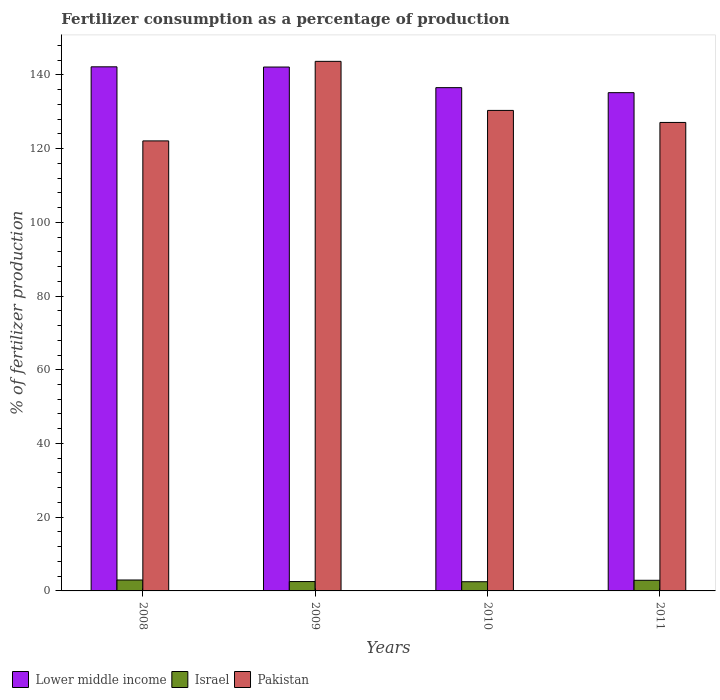How many groups of bars are there?
Keep it short and to the point. 4. What is the percentage of fertilizers consumed in Pakistan in 2010?
Provide a short and direct response. 130.35. Across all years, what is the maximum percentage of fertilizers consumed in Lower middle income?
Your answer should be compact. 142.18. Across all years, what is the minimum percentage of fertilizers consumed in Pakistan?
Keep it short and to the point. 122.08. In which year was the percentage of fertilizers consumed in Pakistan maximum?
Offer a very short reply. 2009. What is the total percentage of fertilizers consumed in Israel in the graph?
Your response must be concise. 10.88. What is the difference between the percentage of fertilizers consumed in Israel in 2008 and that in 2009?
Ensure brevity in your answer.  0.42. What is the difference between the percentage of fertilizers consumed in Lower middle income in 2011 and the percentage of fertilizers consumed in Israel in 2008?
Provide a short and direct response. 132.21. What is the average percentage of fertilizers consumed in Israel per year?
Offer a very short reply. 2.72. In the year 2011, what is the difference between the percentage of fertilizers consumed in Lower middle income and percentage of fertilizers consumed in Pakistan?
Offer a terse response. 8.08. What is the ratio of the percentage of fertilizers consumed in Pakistan in 2009 to that in 2011?
Offer a terse response. 1.13. Is the difference between the percentage of fertilizers consumed in Lower middle income in 2008 and 2010 greater than the difference between the percentage of fertilizers consumed in Pakistan in 2008 and 2010?
Your answer should be very brief. Yes. What is the difference between the highest and the second highest percentage of fertilizers consumed in Lower middle income?
Make the answer very short. 0.06. What is the difference between the highest and the lowest percentage of fertilizers consumed in Pakistan?
Give a very brief answer. 21.58. In how many years, is the percentage of fertilizers consumed in Lower middle income greater than the average percentage of fertilizers consumed in Lower middle income taken over all years?
Give a very brief answer. 2. Is the sum of the percentage of fertilizers consumed in Lower middle income in 2008 and 2009 greater than the maximum percentage of fertilizers consumed in Pakistan across all years?
Ensure brevity in your answer.  Yes. What does the 3rd bar from the left in 2008 represents?
Make the answer very short. Pakistan. What does the 3rd bar from the right in 2011 represents?
Offer a terse response. Lower middle income. Is it the case that in every year, the sum of the percentage of fertilizers consumed in Israel and percentage of fertilizers consumed in Pakistan is greater than the percentage of fertilizers consumed in Lower middle income?
Your answer should be compact. No. Are all the bars in the graph horizontal?
Your answer should be very brief. No. How many years are there in the graph?
Offer a very short reply. 4. Are the values on the major ticks of Y-axis written in scientific E-notation?
Your response must be concise. No. Does the graph contain grids?
Give a very brief answer. No. How are the legend labels stacked?
Your answer should be compact. Horizontal. What is the title of the graph?
Make the answer very short. Fertilizer consumption as a percentage of production. What is the label or title of the Y-axis?
Your answer should be very brief. % of fertilizer production. What is the % of fertilizer production in Lower middle income in 2008?
Your answer should be very brief. 142.18. What is the % of fertilizer production of Israel in 2008?
Your answer should be very brief. 2.96. What is the % of fertilizer production in Pakistan in 2008?
Your response must be concise. 122.08. What is the % of fertilizer production in Lower middle income in 2009?
Keep it short and to the point. 142.12. What is the % of fertilizer production in Israel in 2009?
Offer a terse response. 2.54. What is the % of fertilizer production in Pakistan in 2009?
Your answer should be very brief. 143.66. What is the % of fertilizer production in Lower middle income in 2010?
Offer a terse response. 136.53. What is the % of fertilizer production in Israel in 2010?
Offer a terse response. 2.49. What is the % of fertilizer production of Pakistan in 2010?
Give a very brief answer. 130.35. What is the % of fertilizer production in Lower middle income in 2011?
Your answer should be very brief. 135.17. What is the % of fertilizer production of Israel in 2011?
Keep it short and to the point. 2.88. What is the % of fertilizer production in Pakistan in 2011?
Ensure brevity in your answer.  127.09. Across all years, what is the maximum % of fertilizer production in Lower middle income?
Offer a terse response. 142.18. Across all years, what is the maximum % of fertilizer production of Israel?
Make the answer very short. 2.96. Across all years, what is the maximum % of fertilizer production of Pakistan?
Ensure brevity in your answer.  143.66. Across all years, what is the minimum % of fertilizer production of Lower middle income?
Keep it short and to the point. 135.17. Across all years, what is the minimum % of fertilizer production in Israel?
Ensure brevity in your answer.  2.49. Across all years, what is the minimum % of fertilizer production of Pakistan?
Keep it short and to the point. 122.08. What is the total % of fertilizer production of Lower middle income in the graph?
Offer a very short reply. 555.99. What is the total % of fertilizer production of Israel in the graph?
Your response must be concise. 10.88. What is the total % of fertilizer production of Pakistan in the graph?
Keep it short and to the point. 523.18. What is the difference between the % of fertilizer production in Lower middle income in 2008 and that in 2009?
Offer a very short reply. 0.06. What is the difference between the % of fertilizer production of Israel in 2008 and that in 2009?
Ensure brevity in your answer.  0.42. What is the difference between the % of fertilizer production in Pakistan in 2008 and that in 2009?
Provide a succinct answer. -21.58. What is the difference between the % of fertilizer production in Lower middle income in 2008 and that in 2010?
Give a very brief answer. 5.65. What is the difference between the % of fertilizer production in Israel in 2008 and that in 2010?
Ensure brevity in your answer.  0.47. What is the difference between the % of fertilizer production of Pakistan in 2008 and that in 2010?
Give a very brief answer. -8.27. What is the difference between the % of fertilizer production of Lower middle income in 2008 and that in 2011?
Ensure brevity in your answer.  7.01. What is the difference between the % of fertilizer production in Israel in 2008 and that in 2011?
Offer a very short reply. 0.08. What is the difference between the % of fertilizer production of Pakistan in 2008 and that in 2011?
Offer a very short reply. -5.01. What is the difference between the % of fertilizer production of Lower middle income in 2009 and that in 2010?
Keep it short and to the point. 5.59. What is the difference between the % of fertilizer production of Israel in 2009 and that in 2010?
Your response must be concise. 0.05. What is the difference between the % of fertilizer production of Pakistan in 2009 and that in 2010?
Offer a terse response. 13.31. What is the difference between the % of fertilizer production in Lower middle income in 2009 and that in 2011?
Provide a short and direct response. 6.95. What is the difference between the % of fertilizer production of Israel in 2009 and that in 2011?
Your answer should be very brief. -0.34. What is the difference between the % of fertilizer production in Pakistan in 2009 and that in 2011?
Give a very brief answer. 16.57. What is the difference between the % of fertilizer production in Lower middle income in 2010 and that in 2011?
Your answer should be very brief. 1.36. What is the difference between the % of fertilizer production of Israel in 2010 and that in 2011?
Ensure brevity in your answer.  -0.39. What is the difference between the % of fertilizer production of Pakistan in 2010 and that in 2011?
Offer a terse response. 3.26. What is the difference between the % of fertilizer production of Lower middle income in 2008 and the % of fertilizer production of Israel in 2009?
Give a very brief answer. 139.64. What is the difference between the % of fertilizer production of Lower middle income in 2008 and the % of fertilizer production of Pakistan in 2009?
Provide a short and direct response. -1.48. What is the difference between the % of fertilizer production in Israel in 2008 and the % of fertilizer production in Pakistan in 2009?
Offer a terse response. -140.7. What is the difference between the % of fertilizer production of Lower middle income in 2008 and the % of fertilizer production of Israel in 2010?
Your answer should be compact. 139.68. What is the difference between the % of fertilizer production in Lower middle income in 2008 and the % of fertilizer production in Pakistan in 2010?
Provide a succinct answer. 11.83. What is the difference between the % of fertilizer production in Israel in 2008 and the % of fertilizer production in Pakistan in 2010?
Your answer should be compact. -127.39. What is the difference between the % of fertilizer production of Lower middle income in 2008 and the % of fertilizer production of Israel in 2011?
Your answer should be very brief. 139.29. What is the difference between the % of fertilizer production in Lower middle income in 2008 and the % of fertilizer production in Pakistan in 2011?
Your answer should be very brief. 15.09. What is the difference between the % of fertilizer production of Israel in 2008 and the % of fertilizer production of Pakistan in 2011?
Your response must be concise. -124.13. What is the difference between the % of fertilizer production in Lower middle income in 2009 and the % of fertilizer production in Israel in 2010?
Offer a terse response. 139.62. What is the difference between the % of fertilizer production in Lower middle income in 2009 and the % of fertilizer production in Pakistan in 2010?
Offer a terse response. 11.77. What is the difference between the % of fertilizer production of Israel in 2009 and the % of fertilizer production of Pakistan in 2010?
Ensure brevity in your answer.  -127.81. What is the difference between the % of fertilizer production in Lower middle income in 2009 and the % of fertilizer production in Israel in 2011?
Your response must be concise. 139.23. What is the difference between the % of fertilizer production in Lower middle income in 2009 and the % of fertilizer production in Pakistan in 2011?
Offer a very short reply. 15.03. What is the difference between the % of fertilizer production of Israel in 2009 and the % of fertilizer production of Pakistan in 2011?
Make the answer very short. -124.55. What is the difference between the % of fertilizer production in Lower middle income in 2010 and the % of fertilizer production in Israel in 2011?
Your response must be concise. 133.64. What is the difference between the % of fertilizer production in Lower middle income in 2010 and the % of fertilizer production in Pakistan in 2011?
Your answer should be compact. 9.44. What is the difference between the % of fertilizer production in Israel in 2010 and the % of fertilizer production in Pakistan in 2011?
Your response must be concise. -124.6. What is the average % of fertilizer production in Lower middle income per year?
Your answer should be very brief. 139. What is the average % of fertilizer production in Israel per year?
Ensure brevity in your answer.  2.72. What is the average % of fertilizer production of Pakistan per year?
Keep it short and to the point. 130.8. In the year 2008, what is the difference between the % of fertilizer production in Lower middle income and % of fertilizer production in Israel?
Your answer should be very brief. 139.22. In the year 2008, what is the difference between the % of fertilizer production of Lower middle income and % of fertilizer production of Pakistan?
Ensure brevity in your answer.  20.1. In the year 2008, what is the difference between the % of fertilizer production of Israel and % of fertilizer production of Pakistan?
Your answer should be very brief. -119.12. In the year 2009, what is the difference between the % of fertilizer production of Lower middle income and % of fertilizer production of Israel?
Provide a short and direct response. 139.58. In the year 2009, what is the difference between the % of fertilizer production of Lower middle income and % of fertilizer production of Pakistan?
Provide a succinct answer. -1.54. In the year 2009, what is the difference between the % of fertilizer production in Israel and % of fertilizer production in Pakistan?
Keep it short and to the point. -141.12. In the year 2010, what is the difference between the % of fertilizer production of Lower middle income and % of fertilizer production of Israel?
Offer a terse response. 134.03. In the year 2010, what is the difference between the % of fertilizer production in Lower middle income and % of fertilizer production in Pakistan?
Your answer should be very brief. 6.18. In the year 2010, what is the difference between the % of fertilizer production in Israel and % of fertilizer production in Pakistan?
Your answer should be very brief. -127.86. In the year 2011, what is the difference between the % of fertilizer production of Lower middle income and % of fertilizer production of Israel?
Provide a short and direct response. 132.28. In the year 2011, what is the difference between the % of fertilizer production in Lower middle income and % of fertilizer production in Pakistan?
Provide a succinct answer. 8.08. In the year 2011, what is the difference between the % of fertilizer production in Israel and % of fertilizer production in Pakistan?
Your answer should be very brief. -124.21. What is the ratio of the % of fertilizer production in Israel in 2008 to that in 2009?
Offer a very short reply. 1.17. What is the ratio of the % of fertilizer production in Pakistan in 2008 to that in 2009?
Provide a succinct answer. 0.85. What is the ratio of the % of fertilizer production in Lower middle income in 2008 to that in 2010?
Your answer should be very brief. 1.04. What is the ratio of the % of fertilizer production of Israel in 2008 to that in 2010?
Offer a terse response. 1.19. What is the ratio of the % of fertilizer production in Pakistan in 2008 to that in 2010?
Make the answer very short. 0.94. What is the ratio of the % of fertilizer production of Lower middle income in 2008 to that in 2011?
Make the answer very short. 1.05. What is the ratio of the % of fertilizer production of Israel in 2008 to that in 2011?
Offer a terse response. 1.03. What is the ratio of the % of fertilizer production of Pakistan in 2008 to that in 2011?
Keep it short and to the point. 0.96. What is the ratio of the % of fertilizer production of Lower middle income in 2009 to that in 2010?
Provide a short and direct response. 1.04. What is the ratio of the % of fertilizer production of Israel in 2009 to that in 2010?
Keep it short and to the point. 1.02. What is the ratio of the % of fertilizer production of Pakistan in 2009 to that in 2010?
Offer a very short reply. 1.1. What is the ratio of the % of fertilizer production in Lower middle income in 2009 to that in 2011?
Your answer should be compact. 1.05. What is the ratio of the % of fertilizer production of Israel in 2009 to that in 2011?
Provide a succinct answer. 0.88. What is the ratio of the % of fertilizer production of Pakistan in 2009 to that in 2011?
Your response must be concise. 1.13. What is the ratio of the % of fertilizer production of Israel in 2010 to that in 2011?
Make the answer very short. 0.86. What is the ratio of the % of fertilizer production of Pakistan in 2010 to that in 2011?
Ensure brevity in your answer.  1.03. What is the difference between the highest and the second highest % of fertilizer production in Lower middle income?
Offer a terse response. 0.06. What is the difference between the highest and the second highest % of fertilizer production in Israel?
Give a very brief answer. 0.08. What is the difference between the highest and the second highest % of fertilizer production of Pakistan?
Your answer should be compact. 13.31. What is the difference between the highest and the lowest % of fertilizer production in Lower middle income?
Offer a very short reply. 7.01. What is the difference between the highest and the lowest % of fertilizer production of Israel?
Provide a succinct answer. 0.47. What is the difference between the highest and the lowest % of fertilizer production of Pakistan?
Keep it short and to the point. 21.58. 